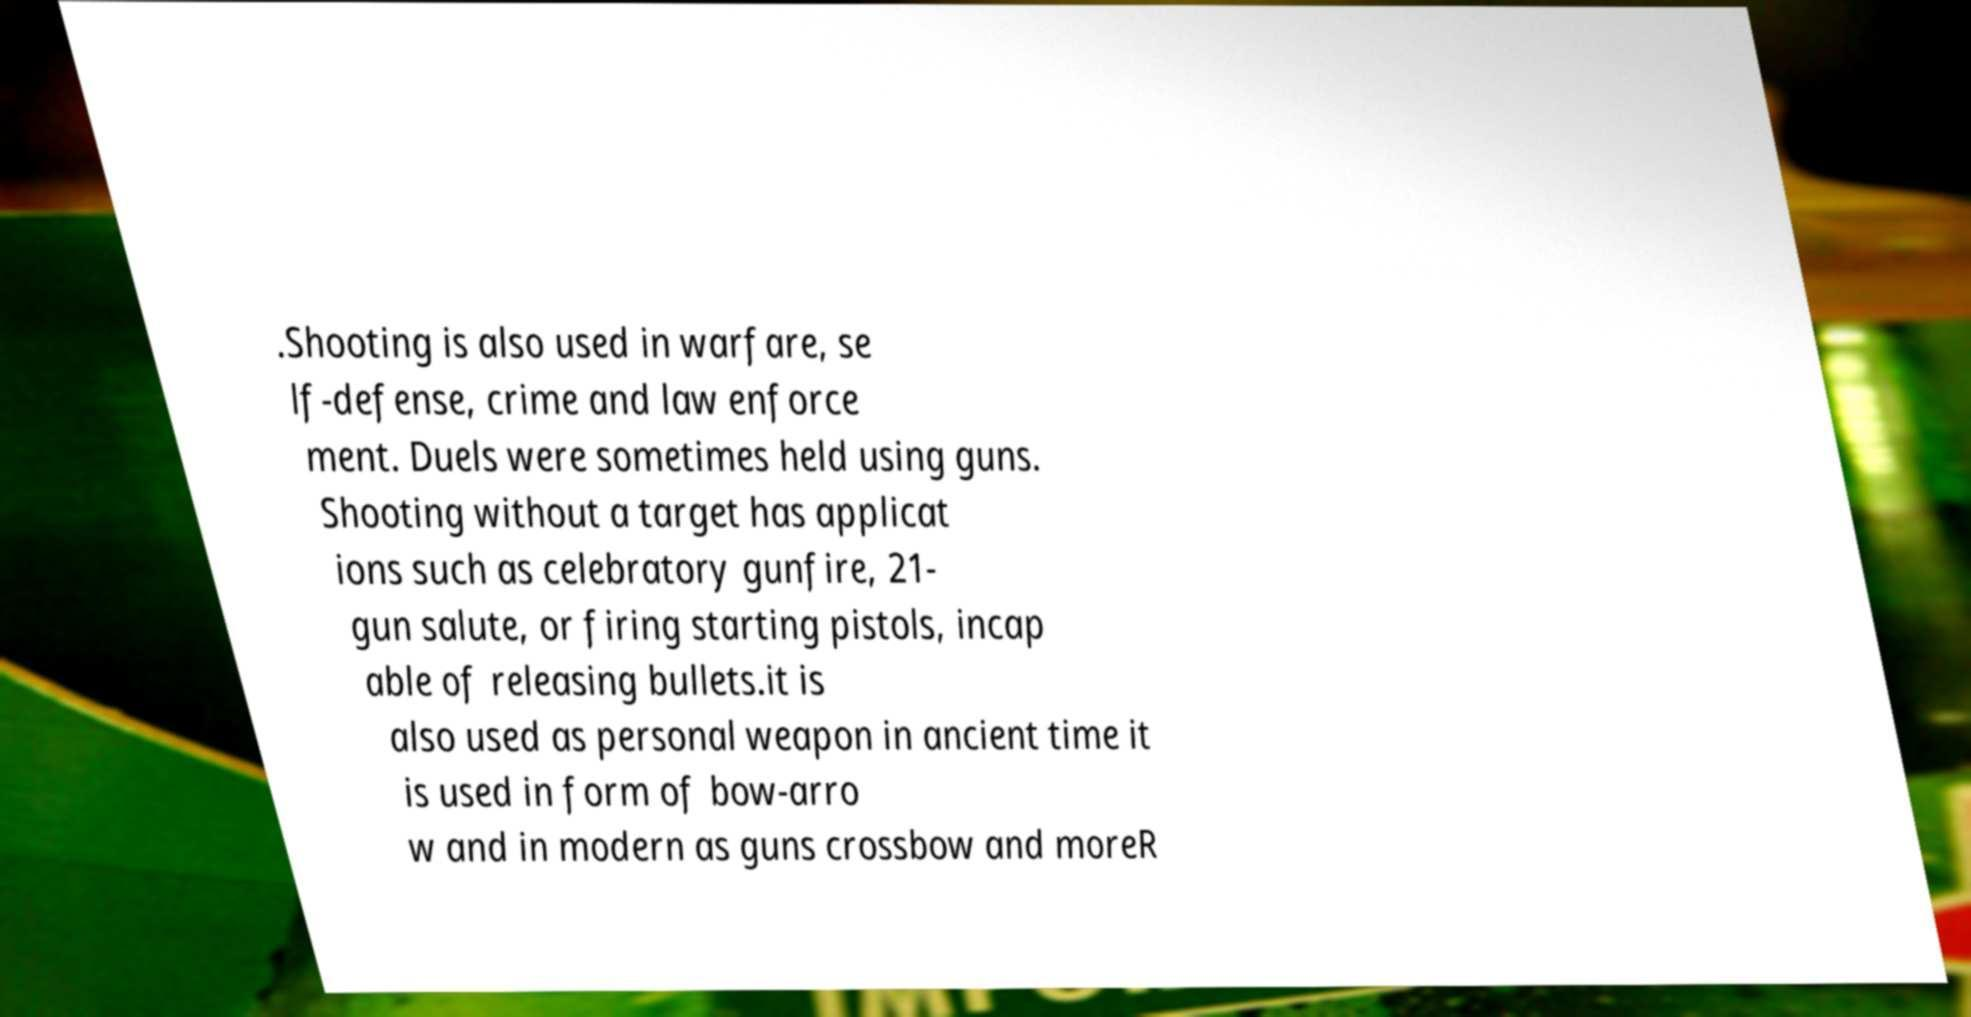What messages or text are displayed in this image? I need them in a readable, typed format. .Shooting is also used in warfare, se lf-defense, crime and law enforce ment. Duels were sometimes held using guns. Shooting without a target has applicat ions such as celebratory gunfire, 21- gun salute, or firing starting pistols, incap able of releasing bullets.it is also used as personal weapon in ancient time it is used in form of bow-arro w and in modern as guns crossbow and moreR 